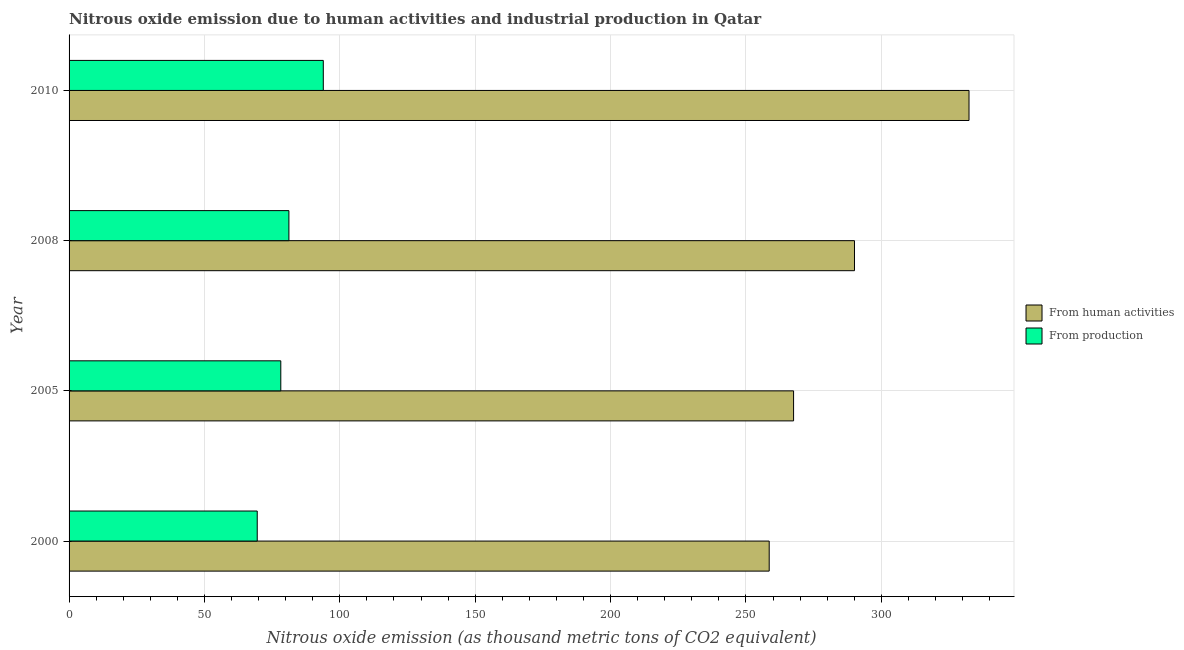How many different coloured bars are there?
Your response must be concise. 2. How many groups of bars are there?
Offer a very short reply. 4. How many bars are there on the 3rd tick from the bottom?
Your answer should be compact. 2. What is the amount of emissions generated from industries in 2010?
Offer a terse response. 93.9. Across all years, what is the maximum amount of emissions from human activities?
Make the answer very short. 332.4. Across all years, what is the minimum amount of emissions generated from industries?
Offer a terse response. 69.5. In which year was the amount of emissions generated from industries minimum?
Ensure brevity in your answer.  2000. What is the total amount of emissions generated from industries in the graph?
Make the answer very short. 322.8. What is the difference between the amount of emissions generated from industries in 2000 and the amount of emissions from human activities in 2008?
Ensure brevity in your answer.  -220.6. What is the average amount of emissions generated from industries per year?
Ensure brevity in your answer.  80.7. In the year 2008, what is the difference between the amount of emissions generated from industries and amount of emissions from human activities?
Give a very brief answer. -208.9. What is the ratio of the amount of emissions generated from industries in 2000 to that in 2008?
Provide a succinct answer. 0.86. Is the amount of emissions from human activities in 2000 less than that in 2008?
Provide a succinct answer. Yes. What is the difference between the highest and the second highest amount of emissions from human activities?
Keep it short and to the point. 42.3. What is the difference between the highest and the lowest amount of emissions from human activities?
Offer a very short reply. 73.8. In how many years, is the amount of emissions from human activities greater than the average amount of emissions from human activities taken over all years?
Provide a short and direct response. 2. Is the sum of the amount of emissions generated from industries in 2000 and 2008 greater than the maximum amount of emissions from human activities across all years?
Your answer should be compact. No. What does the 1st bar from the top in 2000 represents?
Your response must be concise. From production. What does the 2nd bar from the bottom in 2000 represents?
Your answer should be compact. From production. How many bars are there?
Your response must be concise. 8. Are all the bars in the graph horizontal?
Offer a terse response. Yes. How many years are there in the graph?
Provide a short and direct response. 4. Does the graph contain any zero values?
Offer a terse response. No. Where does the legend appear in the graph?
Provide a short and direct response. Center right. How many legend labels are there?
Keep it short and to the point. 2. What is the title of the graph?
Offer a terse response. Nitrous oxide emission due to human activities and industrial production in Qatar. What is the label or title of the X-axis?
Keep it short and to the point. Nitrous oxide emission (as thousand metric tons of CO2 equivalent). What is the label or title of the Y-axis?
Provide a succinct answer. Year. What is the Nitrous oxide emission (as thousand metric tons of CO2 equivalent) of From human activities in 2000?
Your response must be concise. 258.6. What is the Nitrous oxide emission (as thousand metric tons of CO2 equivalent) of From production in 2000?
Offer a terse response. 69.5. What is the Nitrous oxide emission (as thousand metric tons of CO2 equivalent) in From human activities in 2005?
Ensure brevity in your answer.  267.6. What is the Nitrous oxide emission (as thousand metric tons of CO2 equivalent) in From production in 2005?
Ensure brevity in your answer.  78.2. What is the Nitrous oxide emission (as thousand metric tons of CO2 equivalent) in From human activities in 2008?
Make the answer very short. 290.1. What is the Nitrous oxide emission (as thousand metric tons of CO2 equivalent) in From production in 2008?
Offer a terse response. 81.2. What is the Nitrous oxide emission (as thousand metric tons of CO2 equivalent) in From human activities in 2010?
Give a very brief answer. 332.4. What is the Nitrous oxide emission (as thousand metric tons of CO2 equivalent) of From production in 2010?
Your answer should be compact. 93.9. Across all years, what is the maximum Nitrous oxide emission (as thousand metric tons of CO2 equivalent) in From human activities?
Provide a succinct answer. 332.4. Across all years, what is the maximum Nitrous oxide emission (as thousand metric tons of CO2 equivalent) in From production?
Keep it short and to the point. 93.9. Across all years, what is the minimum Nitrous oxide emission (as thousand metric tons of CO2 equivalent) in From human activities?
Keep it short and to the point. 258.6. Across all years, what is the minimum Nitrous oxide emission (as thousand metric tons of CO2 equivalent) of From production?
Ensure brevity in your answer.  69.5. What is the total Nitrous oxide emission (as thousand metric tons of CO2 equivalent) of From human activities in the graph?
Keep it short and to the point. 1148.7. What is the total Nitrous oxide emission (as thousand metric tons of CO2 equivalent) of From production in the graph?
Keep it short and to the point. 322.8. What is the difference between the Nitrous oxide emission (as thousand metric tons of CO2 equivalent) in From production in 2000 and that in 2005?
Your answer should be compact. -8.7. What is the difference between the Nitrous oxide emission (as thousand metric tons of CO2 equivalent) of From human activities in 2000 and that in 2008?
Ensure brevity in your answer.  -31.5. What is the difference between the Nitrous oxide emission (as thousand metric tons of CO2 equivalent) in From human activities in 2000 and that in 2010?
Provide a short and direct response. -73.8. What is the difference between the Nitrous oxide emission (as thousand metric tons of CO2 equivalent) of From production in 2000 and that in 2010?
Offer a terse response. -24.4. What is the difference between the Nitrous oxide emission (as thousand metric tons of CO2 equivalent) in From human activities in 2005 and that in 2008?
Your answer should be very brief. -22.5. What is the difference between the Nitrous oxide emission (as thousand metric tons of CO2 equivalent) of From human activities in 2005 and that in 2010?
Keep it short and to the point. -64.8. What is the difference between the Nitrous oxide emission (as thousand metric tons of CO2 equivalent) in From production in 2005 and that in 2010?
Your answer should be very brief. -15.7. What is the difference between the Nitrous oxide emission (as thousand metric tons of CO2 equivalent) in From human activities in 2008 and that in 2010?
Your answer should be compact. -42.3. What is the difference between the Nitrous oxide emission (as thousand metric tons of CO2 equivalent) of From human activities in 2000 and the Nitrous oxide emission (as thousand metric tons of CO2 equivalent) of From production in 2005?
Give a very brief answer. 180.4. What is the difference between the Nitrous oxide emission (as thousand metric tons of CO2 equivalent) in From human activities in 2000 and the Nitrous oxide emission (as thousand metric tons of CO2 equivalent) in From production in 2008?
Keep it short and to the point. 177.4. What is the difference between the Nitrous oxide emission (as thousand metric tons of CO2 equivalent) in From human activities in 2000 and the Nitrous oxide emission (as thousand metric tons of CO2 equivalent) in From production in 2010?
Keep it short and to the point. 164.7. What is the difference between the Nitrous oxide emission (as thousand metric tons of CO2 equivalent) in From human activities in 2005 and the Nitrous oxide emission (as thousand metric tons of CO2 equivalent) in From production in 2008?
Give a very brief answer. 186.4. What is the difference between the Nitrous oxide emission (as thousand metric tons of CO2 equivalent) in From human activities in 2005 and the Nitrous oxide emission (as thousand metric tons of CO2 equivalent) in From production in 2010?
Your answer should be compact. 173.7. What is the difference between the Nitrous oxide emission (as thousand metric tons of CO2 equivalent) of From human activities in 2008 and the Nitrous oxide emission (as thousand metric tons of CO2 equivalent) of From production in 2010?
Your answer should be very brief. 196.2. What is the average Nitrous oxide emission (as thousand metric tons of CO2 equivalent) of From human activities per year?
Your answer should be very brief. 287.18. What is the average Nitrous oxide emission (as thousand metric tons of CO2 equivalent) in From production per year?
Your response must be concise. 80.7. In the year 2000, what is the difference between the Nitrous oxide emission (as thousand metric tons of CO2 equivalent) of From human activities and Nitrous oxide emission (as thousand metric tons of CO2 equivalent) of From production?
Provide a succinct answer. 189.1. In the year 2005, what is the difference between the Nitrous oxide emission (as thousand metric tons of CO2 equivalent) of From human activities and Nitrous oxide emission (as thousand metric tons of CO2 equivalent) of From production?
Make the answer very short. 189.4. In the year 2008, what is the difference between the Nitrous oxide emission (as thousand metric tons of CO2 equivalent) in From human activities and Nitrous oxide emission (as thousand metric tons of CO2 equivalent) in From production?
Offer a terse response. 208.9. In the year 2010, what is the difference between the Nitrous oxide emission (as thousand metric tons of CO2 equivalent) of From human activities and Nitrous oxide emission (as thousand metric tons of CO2 equivalent) of From production?
Make the answer very short. 238.5. What is the ratio of the Nitrous oxide emission (as thousand metric tons of CO2 equivalent) in From human activities in 2000 to that in 2005?
Your answer should be very brief. 0.97. What is the ratio of the Nitrous oxide emission (as thousand metric tons of CO2 equivalent) of From production in 2000 to that in 2005?
Keep it short and to the point. 0.89. What is the ratio of the Nitrous oxide emission (as thousand metric tons of CO2 equivalent) of From human activities in 2000 to that in 2008?
Provide a succinct answer. 0.89. What is the ratio of the Nitrous oxide emission (as thousand metric tons of CO2 equivalent) in From production in 2000 to that in 2008?
Give a very brief answer. 0.86. What is the ratio of the Nitrous oxide emission (as thousand metric tons of CO2 equivalent) in From human activities in 2000 to that in 2010?
Offer a terse response. 0.78. What is the ratio of the Nitrous oxide emission (as thousand metric tons of CO2 equivalent) of From production in 2000 to that in 2010?
Provide a short and direct response. 0.74. What is the ratio of the Nitrous oxide emission (as thousand metric tons of CO2 equivalent) in From human activities in 2005 to that in 2008?
Ensure brevity in your answer.  0.92. What is the ratio of the Nitrous oxide emission (as thousand metric tons of CO2 equivalent) in From production in 2005 to that in 2008?
Ensure brevity in your answer.  0.96. What is the ratio of the Nitrous oxide emission (as thousand metric tons of CO2 equivalent) of From human activities in 2005 to that in 2010?
Provide a succinct answer. 0.81. What is the ratio of the Nitrous oxide emission (as thousand metric tons of CO2 equivalent) in From production in 2005 to that in 2010?
Make the answer very short. 0.83. What is the ratio of the Nitrous oxide emission (as thousand metric tons of CO2 equivalent) in From human activities in 2008 to that in 2010?
Make the answer very short. 0.87. What is the ratio of the Nitrous oxide emission (as thousand metric tons of CO2 equivalent) in From production in 2008 to that in 2010?
Keep it short and to the point. 0.86. What is the difference between the highest and the second highest Nitrous oxide emission (as thousand metric tons of CO2 equivalent) of From human activities?
Your answer should be compact. 42.3. What is the difference between the highest and the second highest Nitrous oxide emission (as thousand metric tons of CO2 equivalent) of From production?
Give a very brief answer. 12.7. What is the difference between the highest and the lowest Nitrous oxide emission (as thousand metric tons of CO2 equivalent) in From human activities?
Keep it short and to the point. 73.8. What is the difference between the highest and the lowest Nitrous oxide emission (as thousand metric tons of CO2 equivalent) of From production?
Offer a very short reply. 24.4. 